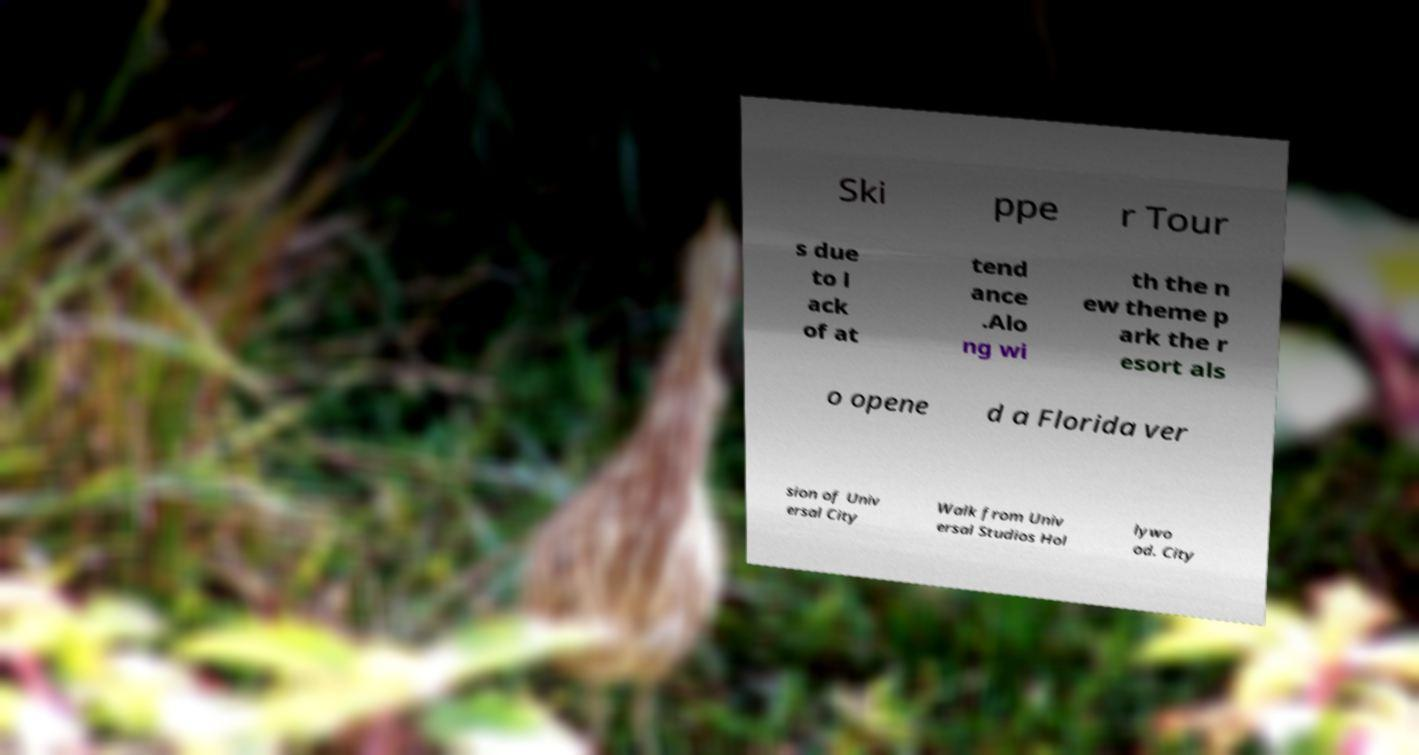Please read and relay the text visible in this image. What does it say? Ski ppe r Tour s due to l ack of at tend ance .Alo ng wi th the n ew theme p ark the r esort als o opene d a Florida ver sion of Univ ersal City Walk from Univ ersal Studios Hol lywo od. City 